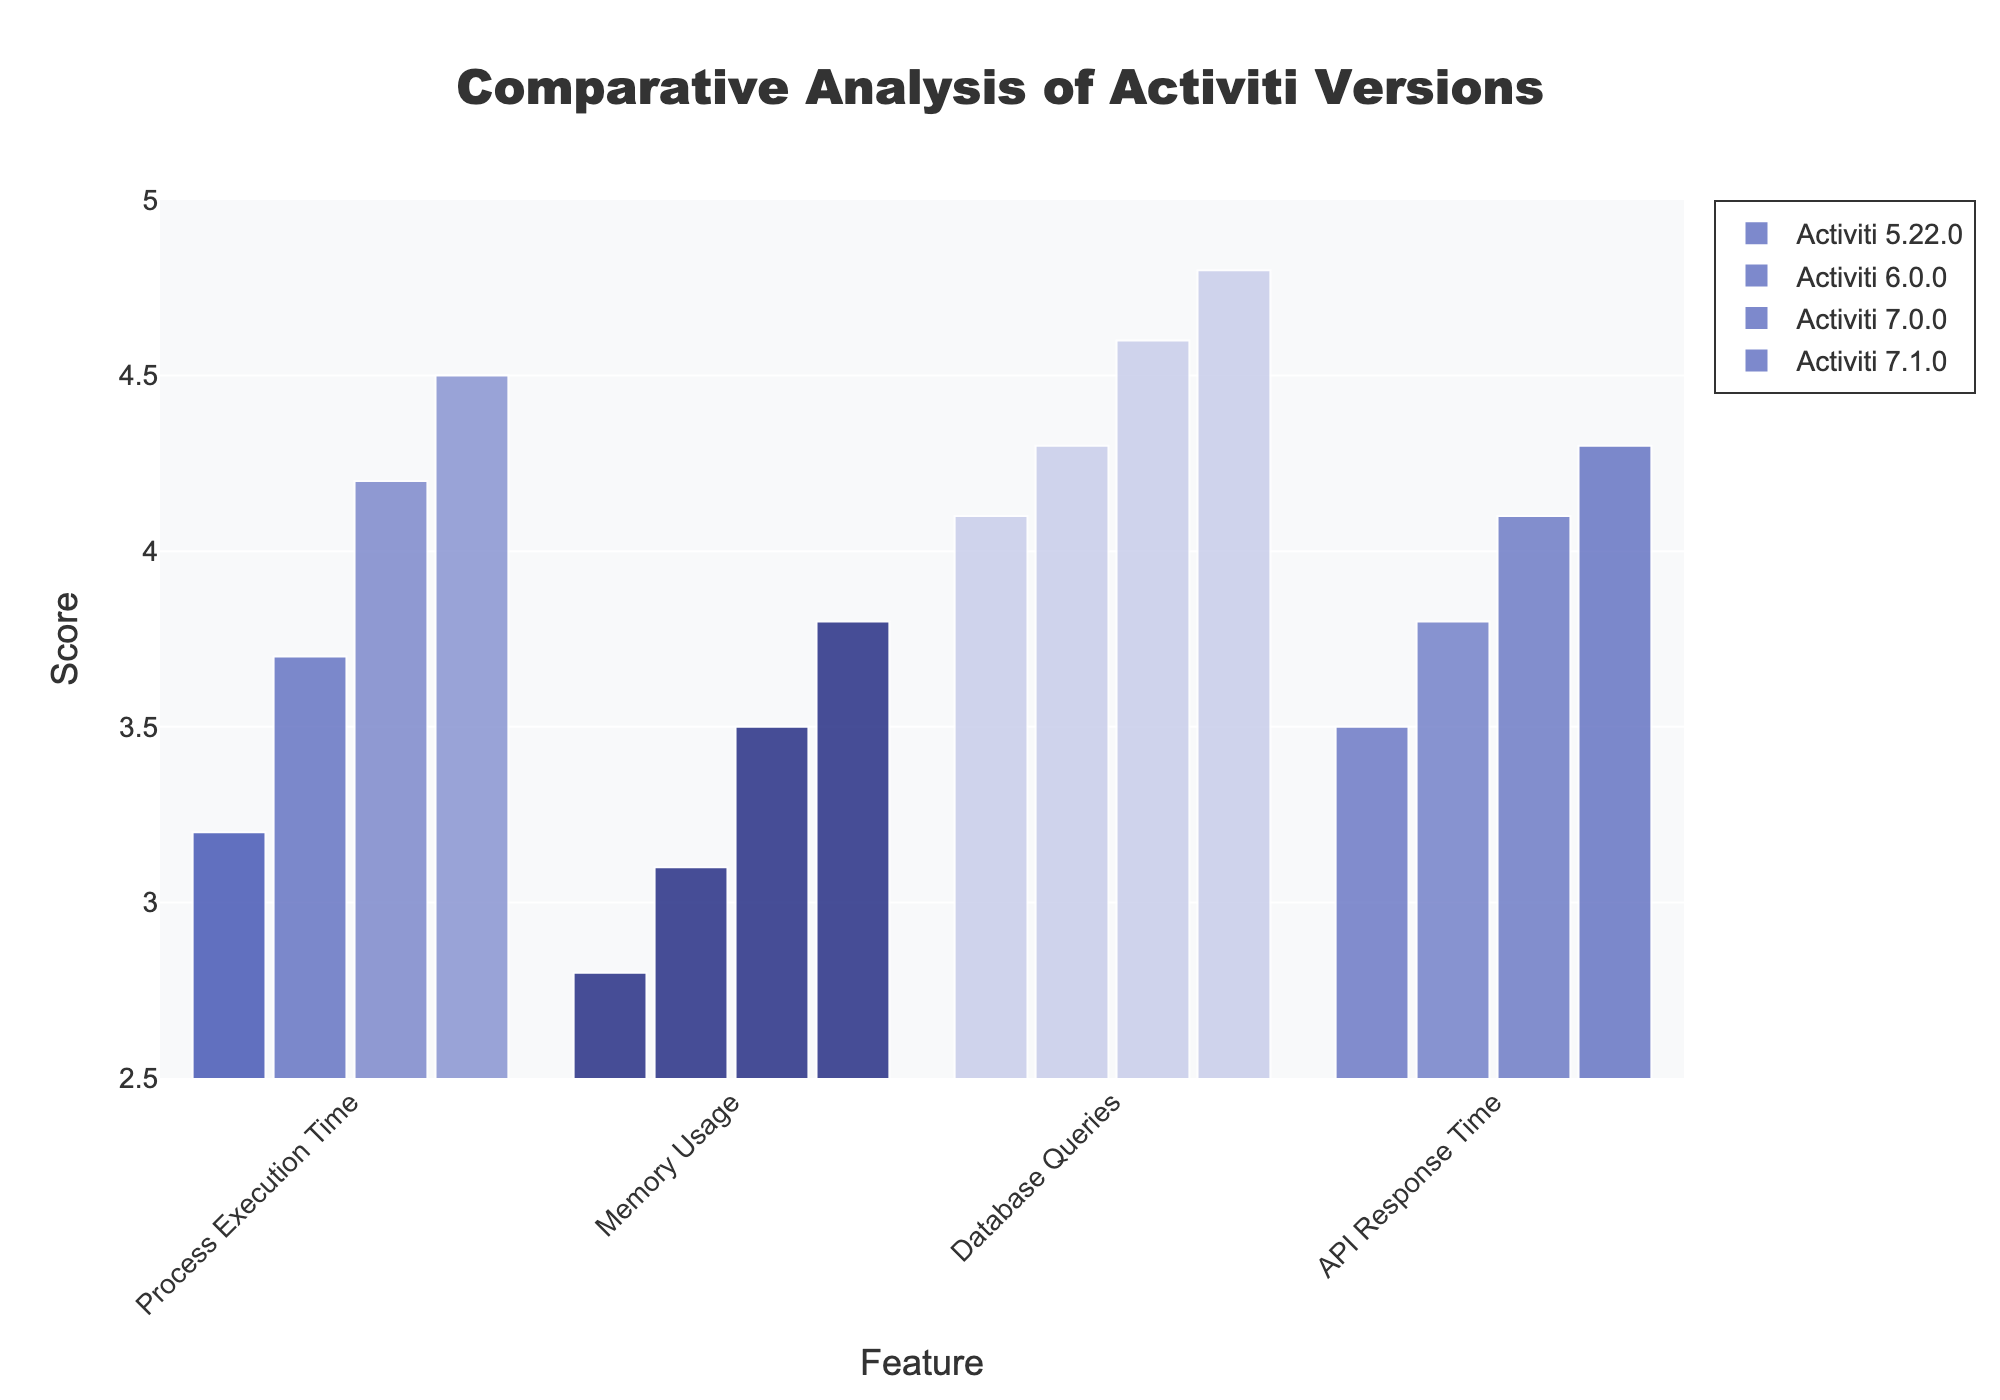What is the title of the plot? The title is usually located at the top of the plot. It gives an overall idea of what the plot represents. In this case, it clearly states 'Comparative Analysis of Activiti Versions'.
Answer: Comparative Analysis of Activiti Versions Which feature has the highest score for Activiti 7.1.0? By looking at the bars for Activiti 7.1.0, you can see that 'Database Queries' has the tallest bar, indicating the highest score.
Answer: Database Queries How many unique features are compared in the plot? The x-axis represents different features being compared. Count the unique names to get the number of unique features. Here, they are Process Execution Time, Memory Usage, Database Queries, and API Response Time.
Answer: 4 For which version does the 'API Response Time' feature have the lowest score? Look at the 'API Response Time' bars for all versions. The shortest bar for 'API Response Time' belongs to Activiti 5.22.0 with a score of 3.5.
Answer: Activiti 5.22.0 What is the average score for all features in Activiti 6.0.0? Add the scores for Process Execution Time (3.7), Memory Usage (3.1), Database Queries (4.3), and API Response Time (3.8). Then divide by 4. (3.7 + 3.1 + 4.3 + 3.8) / 4 = 3.725.
Answer: 3.725 Which version shows the greatest improvement in 'Memory Usage' compared to its previous version? Check the improvements in memory usage: from 5.22.0 to 6.0.0 (2.8 to 3.1, improvement of 0.3), 6.0.0 to 7.0.0 (3.1 to 3.5, improvement of 0.4), and 7.0.0 to 7.1.0 (3.5 to 3.8, improvement of 0.3). Activiti 7.0.0 has the greatest improvement with 0.4.
Answer: Activiti 7.0.0 Which version has the most consistent scores across all features? Consistency means less variation in scores. Calculate the variance for each version. Activiti 6.0.0 has scores 3.7, 3.1, 4.3, 3.8 with a small spread compared to others.
Answer: Activiti 6.0.0 Is there a trend in 'Process Execution Time' scores across versions? Examine the 'Process Execution Time' scores for 5.22.0 (3.2), 6.0.0 (3.7), 7.0.0 (4.2), and 7.1.0 (4.5). The scores increase with each version.
Answer: Increasing trend Which feature has shown the most improvement from Activiti 5.22.0 to Activiti 7.1.0? Compare the differences for each feature: Process Execution Time (3.2 to 4.5, +1.3), Memory Usage (2.8 to 3.8, +1.0), Database Queries (4.1 to 4.8, +0.7), API Response Time (3.5 to 4.3, +0.8). 'Process Execution Time' has the most improvement.
Answer: Process Execution Time What's the score difference between the 'API Response Time' of Activiti 7.0.0 and 7.1.0? Subtract the scores of 7.0.0 and 7.1.0 for 'API Response Time': 4.3 - 4.1 = 0.2.
Answer: 0.2 